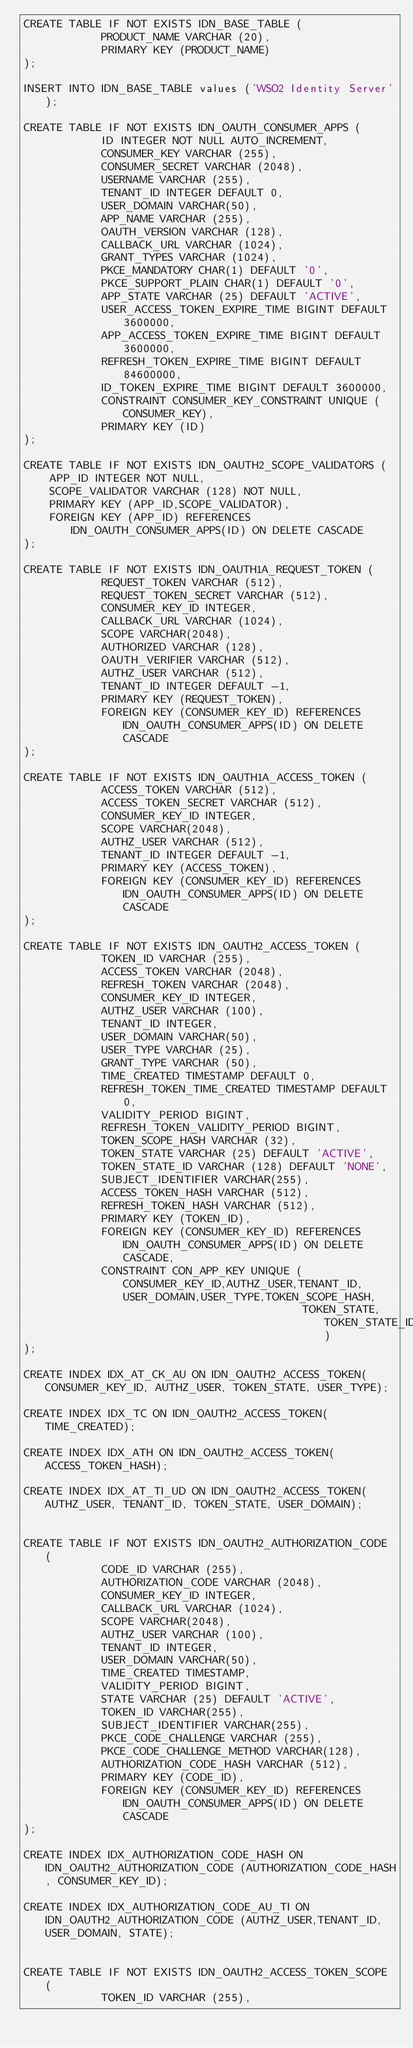<code> <loc_0><loc_0><loc_500><loc_500><_SQL_>CREATE TABLE IF NOT EXISTS IDN_BASE_TABLE (
            PRODUCT_NAME VARCHAR (20),
            PRIMARY KEY (PRODUCT_NAME)
);

INSERT INTO IDN_BASE_TABLE values ('WSO2 Identity Server');

CREATE TABLE IF NOT EXISTS IDN_OAUTH_CONSUMER_APPS (
            ID INTEGER NOT NULL AUTO_INCREMENT,
            CONSUMER_KEY VARCHAR (255),
            CONSUMER_SECRET VARCHAR (2048),
            USERNAME VARCHAR (255),
            TENANT_ID INTEGER DEFAULT 0,
            USER_DOMAIN VARCHAR(50),
            APP_NAME VARCHAR (255),
            OAUTH_VERSION VARCHAR (128),
            CALLBACK_URL VARCHAR (1024),
            GRANT_TYPES VARCHAR (1024),
            PKCE_MANDATORY CHAR(1) DEFAULT '0',
            PKCE_SUPPORT_PLAIN CHAR(1) DEFAULT '0',
            APP_STATE VARCHAR (25) DEFAULT 'ACTIVE',
            USER_ACCESS_TOKEN_EXPIRE_TIME BIGINT DEFAULT 3600000,
            APP_ACCESS_TOKEN_EXPIRE_TIME BIGINT DEFAULT 3600000,
            REFRESH_TOKEN_EXPIRE_TIME BIGINT DEFAULT 84600000,
            ID_TOKEN_EXPIRE_TIME BIGINT DEFAULT 3600000,
            CONSTRAINT CONSUMER_KEY_CONSTRAINT UNIQUE (CONSUMER_KEY),
            PRIMARY KEY (ID)
);

CREATE TABLE IF NOT EXISTS IDN_OAUTH2_SCOPE_VALIDATORS (
	APP_ID INTEGER NOT NULL,
	SCOPE_VALIDATOR VARCHAR (128) NOT NULL,
	PRIMARY KEY (APP_ID,SCOPE_VALIDATOR),
	FOREIGN KEY (APP_ID) REFERENCES IDN_OAUTH_CONSUMER_APPS(ID) ON DELETE CASCADE
);

CREATE TABLE IF NOT EXISTS IDN_OAUTH1A_REQUEST_TOKEN (
            REQUEST_TOKEN VARCHAR (512),
            REQUEST_TOKEN_SECRET VARCHAR (512),
            CONSUMER_KEY_ID INTEGER,
            CALLBACK_URL VARCHAR (1024),
            SCOPE VARCHAR(2048),
            AUTHORIZED VARCHAR (128),
            OAUTH_VERIFIER VARCHAR (512),
            AUTHZ_USER VARCHAR (512),
            TENANT_ID INTEGER DEFAULT -1,
            PRIMARY KEY (REQUEST_TOKEN),
            FOREIGN KEY (CONSUMER_KEY_ID) REFERENCES IDN_OAUTH_CONSUMER_APPS(ID) ON DELETE CASCADE
);

CREATE TABLE IF NOT EXISTS IDN_OAUTH1A_ACCESS_TOKEN (
            ACCESS_TOKEN VARCHAR (512),
            ACCESS_TOKEN_SECRET VARCHAR (512),
            CONSUMER_KEY_ID INTEGER,
            SCOPE VARCHAR(2048),
            AUTHZ_USER VARCHAR (512),
            TENANT_ID INTEGER DEFAULT -1,
            PRIMARY KEY (ACCESS_TOKEN),
            FOREIGN KEY (CONSUMER_KEY_ID) REFERENCES IDN_OAUTH_CONSUMER_APPS(ID) ON DELETE CASCADE
);

CREATE TABLE IF NOT EXISTS IDN_OAUTH2_ACCESS_TOKEN (
            TOKEN_ID VARCHAR (255),
            ACCESS_TOKEN VARCHAR (2048),
            REFRESH_TOKEN VARCHAR (2048),
            CONSUMER_KEY_ID INTEGER,
            AUTHZ_USER VARCHAR (100),
            TENANT_ID INTEGER,
            USER_DOMAIN VARCHAR(50),
            USER_TYPE VARCHAR (25),
            GRANT_TYPE VARCHAR (50),
            TIME_CREATED TIMESTAMP DEFAULT 0,
            REFRESH_TOKEN_TIME_CREATED TIMESTAMP DEFAULT 0,
            VALIDITY_PERIOD BIGINT,
            REFRESH_TOKEN_VALIDITY_PERIOD BIGINT,
            TOKEN_SCOPE_HASH VARCHAR (32),
            TOKEN_STATE VARCHAR (25) DEFAULT 'ACTIVE',
            TOKEN_STATE_ID VARCHAR (128) DEFAULT 'NONE',
            SUBJECT_IDENTIFIER VARCHAR(255),
            ACCESS_TOKEN_HASH VARCHAR (512),
            REFRESH_TOKEN_HASH VARCHAR (512),
            PRIMARY KEY (TOKEN_ID),
            FOREIGN KEY (CONSUMER_KEY_ID) REFERENCES IDN_OAUTH_CONSUMER_APPS(ID) ON DELETE CASCADE,
            CONSTRAINT CON_APP_KEY UNIQUE (CONSUMER_KEY_ID,AUTHZ_USER,TENANT_ID,USER_DOMAIN,USER_TYPE,TOKEN_SCOPE_HASH,
                                           TOKEN_STATE,TOKEN_STATE_ID)
);

CREATE INDEX IDX_AT_CK_AU ON IDN_OAUTH2_ACCESS_TOKEN(CONSUMER_KEY_ID, AUTHZ_USER, TOKEN_STATE, USER_TYPE);

CREATE INDEX IDX_TC ON IDN_OAUTH2_ACCESS_TOKEN(TIME_CREATED);

CREATE INDEX IDX_ATH ON IDN_OAUTH2_ACCESS_TOKEN(ACCESS_TOKEN_HASH);

CREATE INDEX IDX_AT_TI_UD ON IDN_OAUTH2_ACCESS_TOKEN(AUTHZ_USER, TENANT_ID, TOKEN_STATE, USER_DOMAIN);


CREATE TABLE IF NOT EXISTS IDN_OAUTH2_AUTHORIZATION_CODE (
            CODE_ID VARCHAR (255),
            AUTHORIZATION_CODE VARCHAR (2048),
            CONSUMER_KEY_ID INTEGER,
            CALLBACK_URL VARCHAR (1024),
            SCOPE VARCHAR(2048),
            AUTHZ_USER VARCHAR (100),
            TENANT_ID INTEGER,
            USER_DOMAIN VARCHAR(50),
            TIME_CREATED TIMESTAMP,
            VALIDITY_PERIOD BIGINT,
            STATE VARCHAR (25) DEFAULT 'ACTIVE',
            TOKEN_ID VARCHAR(255),
            SUBJECT_IDENTIFIER VARCHAR(255),
            PKCE_CODE_CHALLENGE VARCHAR (255),
            PKCE_CODE_CHALLENGE_METHOD VARCHAR(128),
            AUTHORIZATION_CODE_HASH VARCHAR (512),
            PRIMARY KEY (CODE_ID),
            FOREIGN KEY (CONSUMER_KEY_ID) REFERENCES IDN_OAUTH_CONSUMER_APPS(ID) ON DELETE CASCADE
);

CREATE INDEX IDX_AUTHORIZATION_CODE_HASH ON IDN_OAUTH2_AUTHORIZATION_CODE (AUTHORIZATION_CODE_HASH, CONSUMER_KEY_ID);

CREATE INDEX IDX_AUTHORIZATION_CODE_AU_TI ON IDN_OAUTH2_AUTHORIZATION_CODE (AUTHZ_USER,TENANT_ID, USER_DOMAIN, STATE);


CREATE TABLE IF NOT EXISTS IDN_OAUTH2_ACCESS_TOKEN_SCOPE (
            TOKEN_ID VARCHAR (255),</code> 